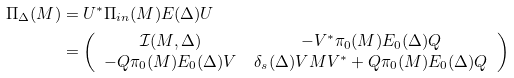<formula> <loc_0><loc_0><loc_500><loc_500>\Pi _ { \Delta } ( M ) & = U ^ { \ast } \Pi _ { i n } ( M ) E ( \Delta ) U \\ & = \left ( \begin{array} { c c } \mathcal { I } ( M , \Delta ) & - V ^ { \ast } \pi _ { 0 } ( M ) E _ { 0 } ( \Delta ) Q \\ - Q \pi _ { 0 } ( M ) E _ { 0 } ( \Delta ) V & \delta _ { s } ( \Delta ) V M V ^ { \ast } + Q \pi _ { 0 } ( M ) E _ { 0 } ( \Delta ) Q \end{array} \right )</formula> 